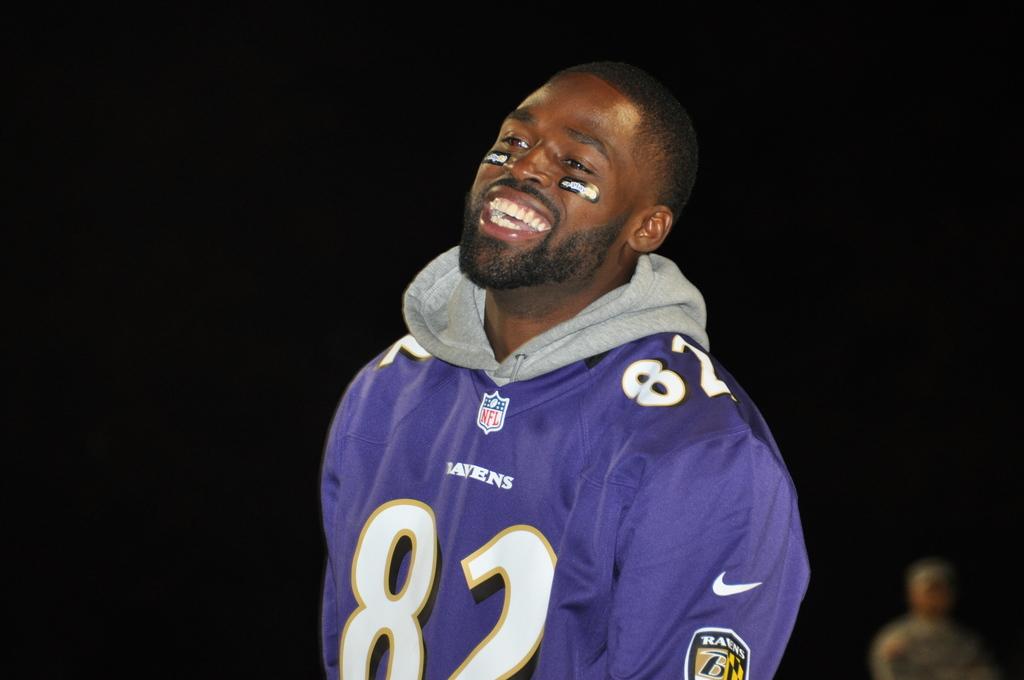What number is he?
Offer a terse response. 82. 